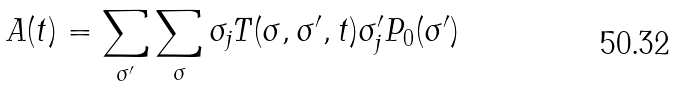Convert formula to latex. <formula><loc_0><loc_0><loc_500><loc_500>A ( t ) = \sum _ { \sigma ^ { \prime } } \sum _ { \sigma } \sigma _ { j } T ( \sigma , \sigma ^ { \prime } , t ) \sigma _ { j } ^ { \prime } P _ { 0 } ( \sigma ^ { \prime } )</formula> 